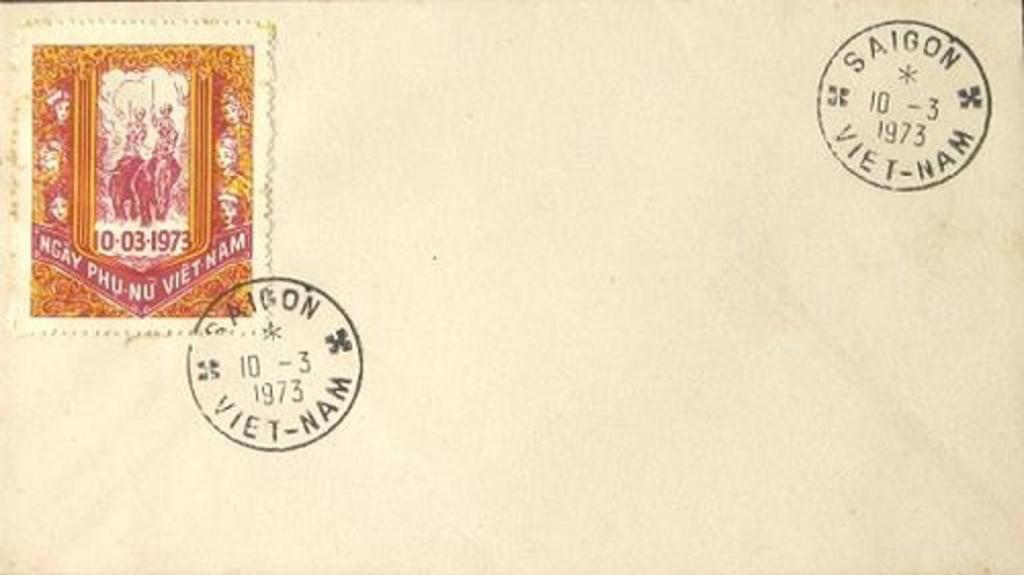<image>
Provide a brief description of the given image. A letter has postmark stamps from Saigon, Vietnam from the year 1973. 